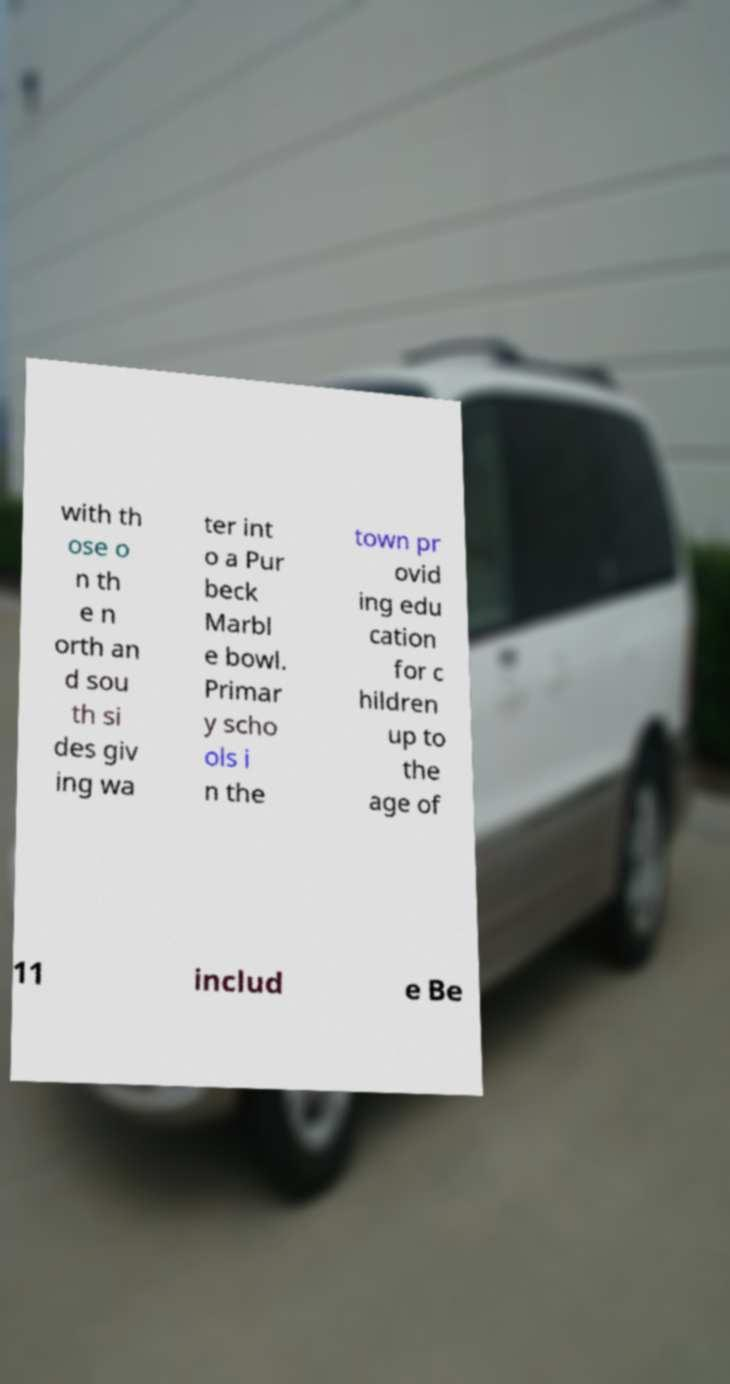I need the written content from this picture converted into text. Can you do that? with th ose o n th e n orth an d sou th si des giv ing wa ter int o a Pur beck Marbl e bowl. Primar y scho ols i n the town pr ovid ing edu cation for c hildren up to the age of 11 includ e Be 